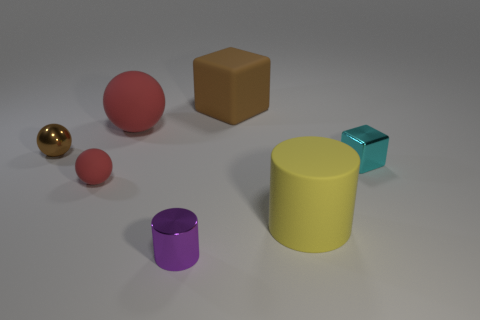There is a yellow thing that is the same shape as the small purple object; what size is it?
Ensure brevity in your answer.  Large. What number of purple cylinders are the same material as the yellow cylinder?
Offer a very short reply. 0. How many objects are either small shiny cylinders or large cylinders?
Your response must be concise. 2. Are there any big things to the right of the red rubber object in front of the big red ball?
Provide a short and direct response. Yes. Are there more big rubber cylinders left of the big matte ball than big rubber blocks on the left side of the purple cylinder?
Offer a terse response. No. There is a big ball that is the same color as the small rubber thing; what is its material?
Offer a terse response. Rubber. How many other shiny balls have the same color as the big sphere?
Give a very brief answer. 0. There is a small metal object that is to the left of the purple metallic cylinder; is it the same color as the small metallic thing that is right of the large yellow cylinder?
Provide a succinct answer. No. There is a brown block; are there any tiny purple metal things on the right side of it?
Offer a very short reply. No. What is the small brown object made of?
Your response must be concise. Metal. 